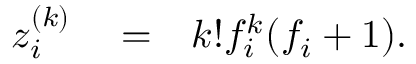Convert formula to latex. <formula><loc_0><loc_0><loc_500><loc_500>\begin{array} { r l r } { z _ { i } ^ { ( k ) } } & = } & { k ! f _ { i } ^ { k } ( f _ { i } + 1 ) . } \end{array}</formula> 